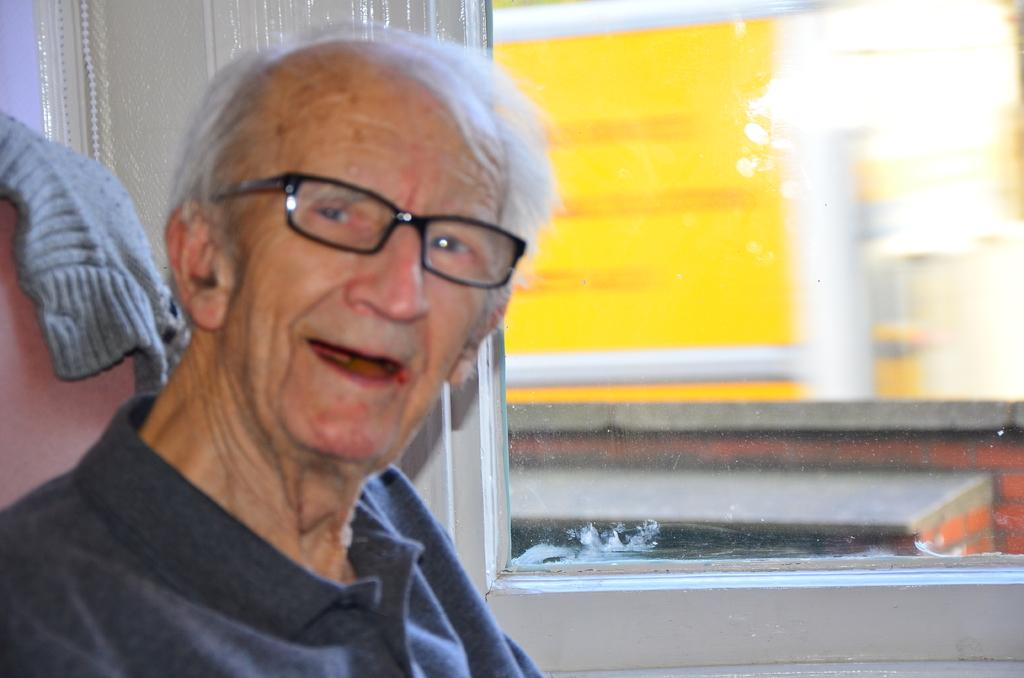Who is the main subject in the image? There is an old man in the image. What is the old man doing in the image? The old man is sitting on a chair and smiling. What can be seen in the background of the image? There is a glass window in the background of the image, and outside buildings are visible through it. What type of mine is the old man operating in the image? There is no mine present in the image; it features an old man sitting on a chair and smiling. What role does the fireman play in the image? There is no fireman present in the image; it features an old man sitting on a chair and smiling. 